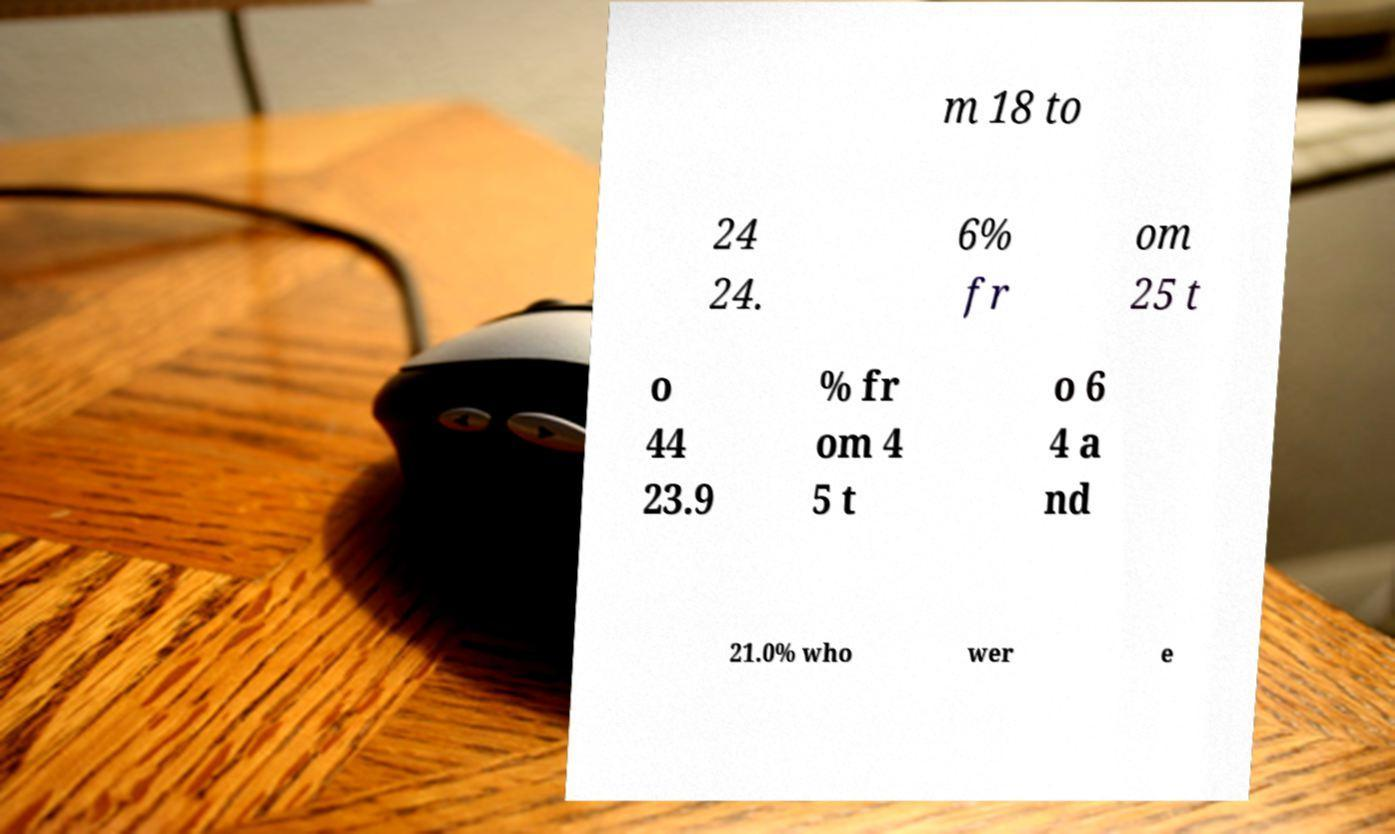Please read and relay the text visible in this image. What does it say? m 18 to 24 24. 6% fr om 25 t o 44 23.9 % fr om 4 5 t o 6 4 a nd 21.0% who wer e 